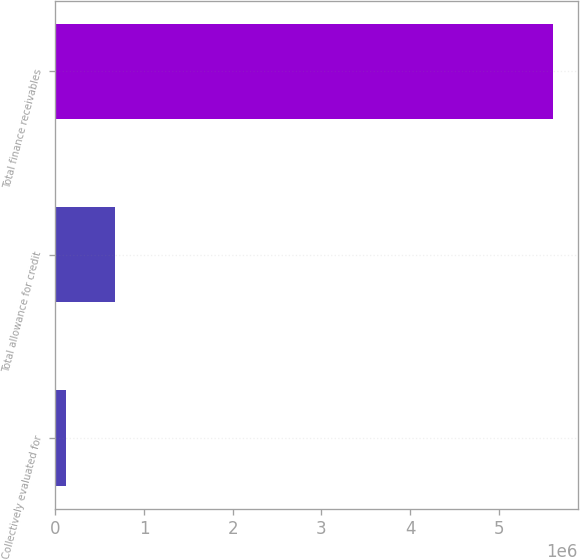Convert chart. <chart><loc_0><loc_0><loc_500><loc_500><bar_chart><fcel>Collectively evaluated for<fcel>Total allowance for credit<fcel>Total finance receivables<nl><fcel>122025<fcel>670615<fcel>5.60792e+06<nl></chart> 